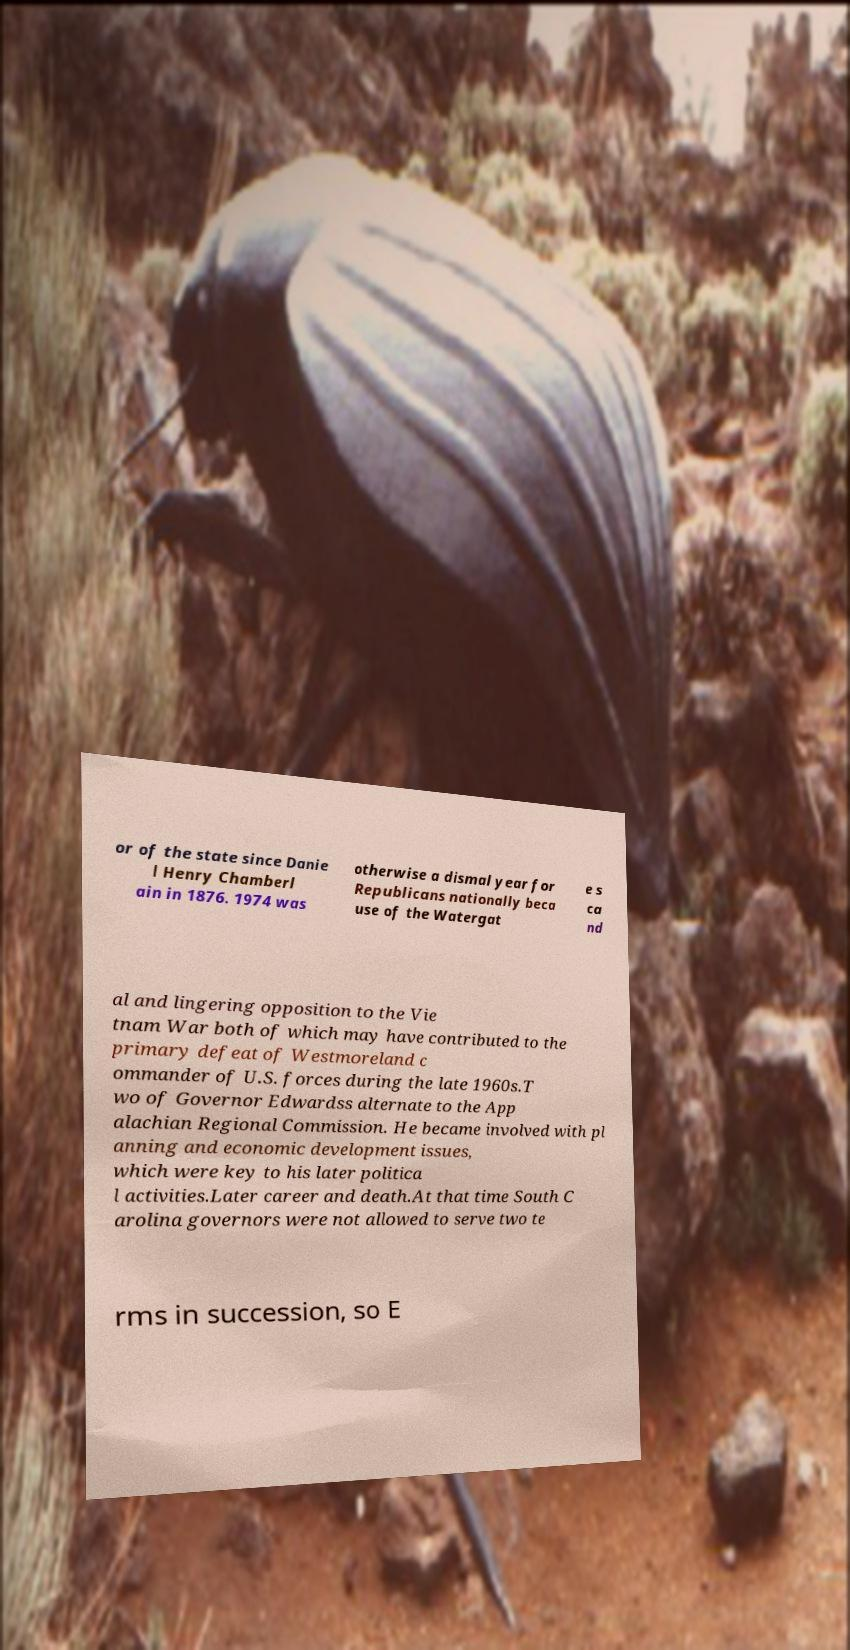For documentation purposes, I need the text within this image transcribed. Could you provide that? or of the state since Danie l Henry Chamberl ain in 1876. 1974 was otherwise a dismal year for Republicans nationally beca use of the Watergat e s ca nd al and lingering opposition to the Vie tnam War both of which may have contributed to the primary defeat of Westmoreland c ommander of U.S. forces during the late 1960s.T wo of Governor Edwardss alternate to the App alachian Regional Commission. He became involved with pl anning and economic development issues, which were key to his later politica l activities.Later career and death.At that time South C arolina governors were not allowed to serve two te rms in succession, so E 